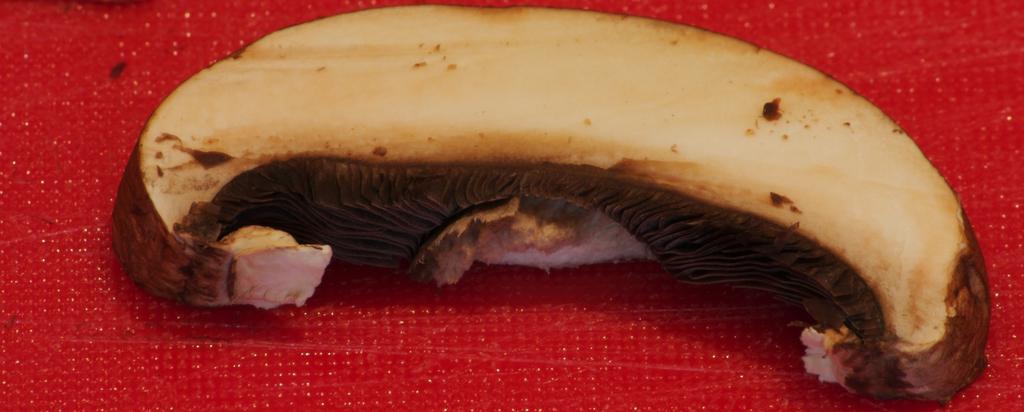Describe this image in one or two sentences. In this picture we can see some food on a red surface. 